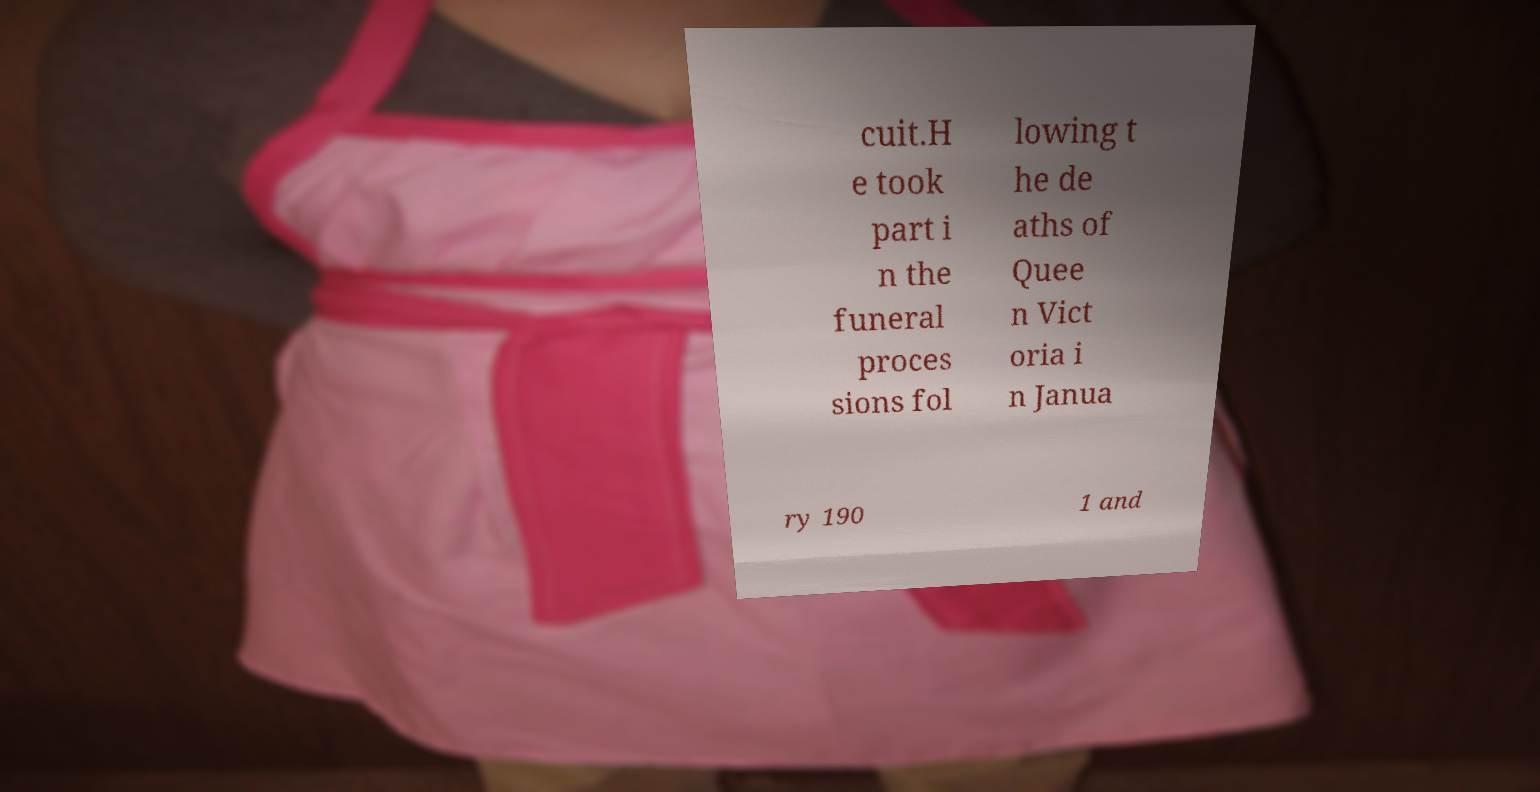Could you assist in decoding the text presented in this image and type it out clearly? cuit.H e took part i n the funeral proces sions fol lowing t he de aths of Quee n Vict oria i n Janua ry 190 1 and 